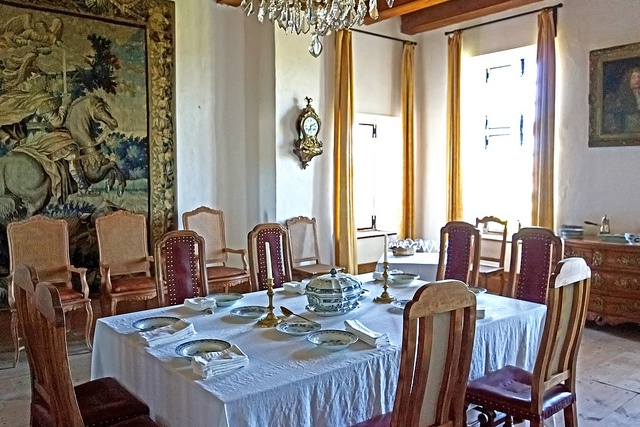Describe the objects in this image and their specific colors. I can see dining table in black, gray, and darkgray tones, chair in black, maroon, and gray tones, chair in black, maroon, and gray tones, chair in black, maroon, and gray tones, and chair in black, brown, gray, and maroon tones in this image. 